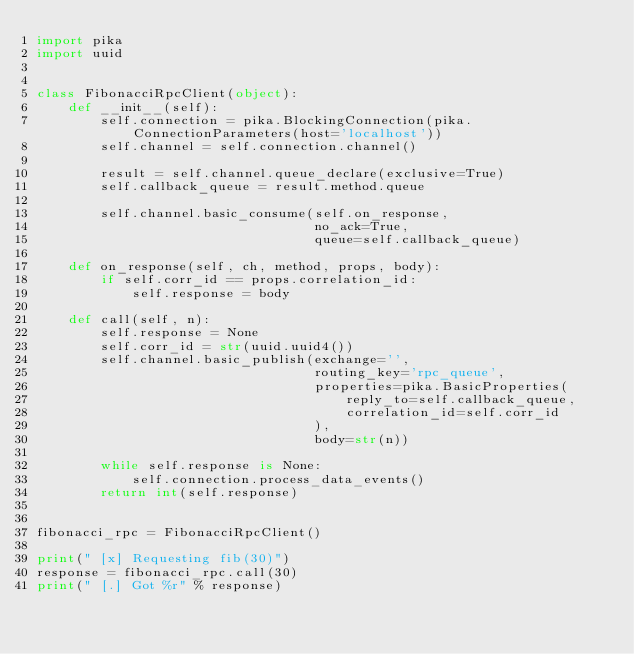Convert code to text. <code><loc_0><loc_0><loc_500><loc_500><_Python_>import pika
import uuid


class FibonacciRpcClient(object):
    def __init__(self):
        self.connection = pika.BlockingConnection(pika.ConnectionParameters(host='localhost'))
        self.channel = self.connection.channel()

        result = self.channel.queue_declare(exclusive=True)
        self.callback_queue = result.method.queue

        self.channel.basic_consume(self.on_response,
                                   no_ack=True,
                                   queue=self.callback_queue)

    def on_response(self, ch, method, props, body):
        if self.corr_id == props.correlation_id:
            self.response = body

    def call(self, n):
        self.response = None
        self.corr_id = str(uuid.uuid4())
        self.channel.basic_publish(exchange='',
                                   routing_key='rpc_queue',
                                   properties=pika.BasicProperties(
                                       reply_to=self.callback_queue,
                                       correlation_id=self.corr_id
                                   ),
                                   body=str(n))

        while self.response is None:
            self.connection.process_data_events()
        return int(self.response)


fibonacci_rpc = FibonacciRpcClient()

print(" [x] Requesting fib(30)")
response = fibonacci_rpc.call(30)
print(" [.] Got %r" % response)
</code> 